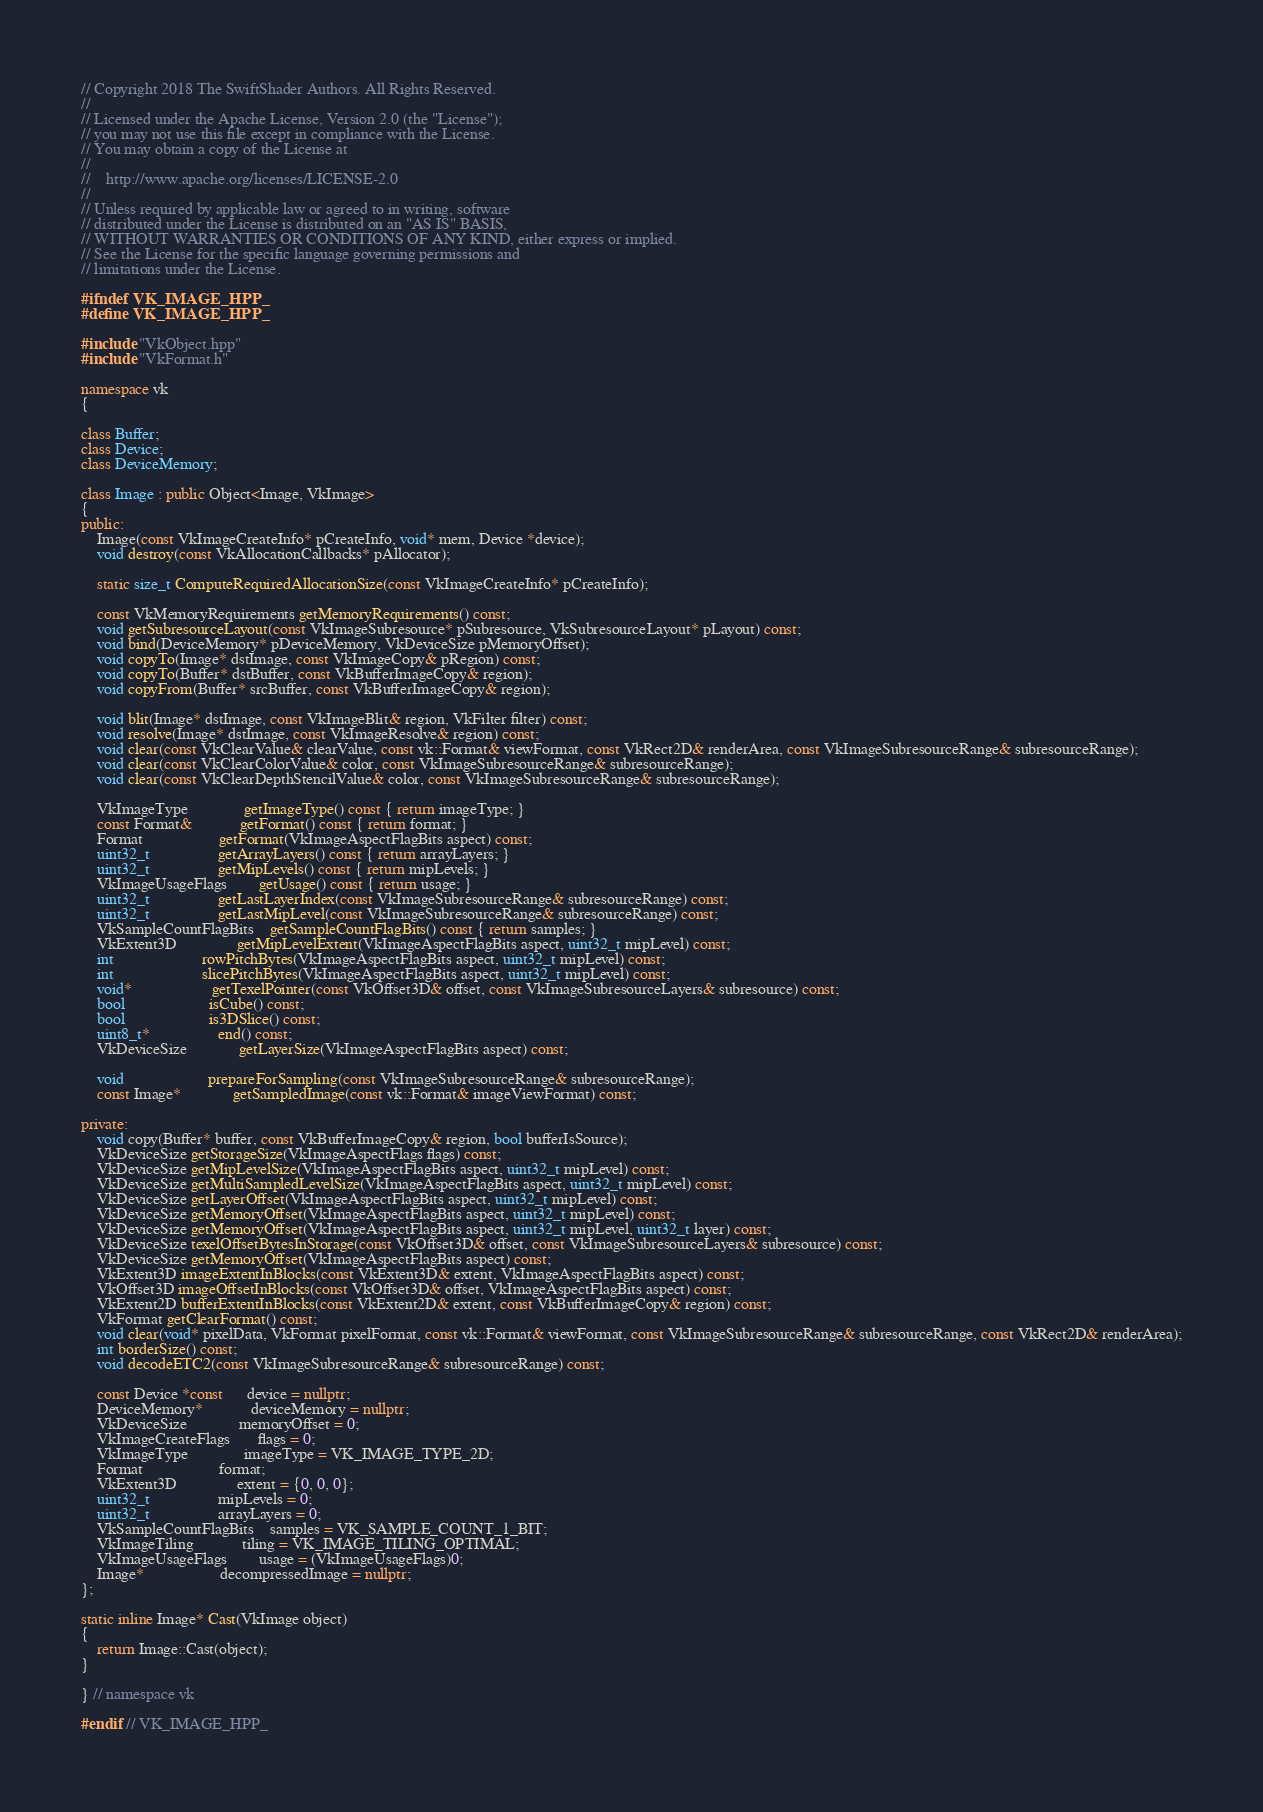<code> <loc_0><loc_0><loc_500><loc_500><_C++_>// Copyright 2018 The SwiftShader Authors. All Rights Reserved.
//
// Licensed under the Apache License, Version 2.0 (the "License");
// you may not use this file except in compliance with the License.
// You may obtain a copy of the License at
//
//    http://www.apache.org/licenses/LICENSE-2.0
//
// Unless required by applicable law or agreed to in writing, software
// distributed under the License is distributed on an "AS IS" BASIS,
// WITHOUT WARRANTIES OR CONDITIONS OF ANY KIND, either express or implied.
// See the License for the specific language governing permissions and
// limitations under the License.

#ifndef VK_IMAGE_HPP_
#define VK_IMAGE_HPP_

#include "VkObject.hpp"
#include "VkFormat.h"

namespace vk
{

class Buffer;
class Device;
class DeviceMemory;

class Image : public Object<Image, VkImage>
{
public:
	Image(const VkImageCreateInfo* pCreateInfo, void* mem, Device *device);
	void destroy(const VkAllocationCallbacks* pAllocator);

	static size_t ComputeRequiredAllocationSize(const VkImageCreateInfo* pCreateInfo);

	const VkMemoryRequirements getMemoryRequirements() const;
	void getSubresourceLayout(const VkImageSubresource* pSubresource, VkSubresourceLayout* pLayout) const;
	void bind(DeviceMemory* pDeviceMemory, VkDeviceSize pMemoryOffset);
	void copyTo(Image* dstImage, const VkImageCopy& pRegion) const;
	void copyTo(Buffer* dstBuffer, const VkBufferImageCopy& region);
	void copyFrom(Buffer* srcBuffer, const VkBufferImageCopy& region);

	void blit(Image* dstImage, const VkImageBlit& region, VkFilter filter) const;
	void resolve(Image* dstImage, const VkImageResolve& region) const;
	void clear(const VkClearValue& clearValue, const vk::Format& viewFormat, const VkRect2D& renderArea, const VkImageSubresourceRange& subresourceRange);
	void clear(const VkClearColorValue& color, const VkImageSubresourceRange& subresourceRange);
	void clear(const VkClearDepthStencilValue& color, const VkImageSubresourceRange& subresourceRange);

	VkImageType              getImageType() const { return imageType; }
	const Format&            getFormat() const { return format; }
	Format                   getFormat(VkImageAspectFlagBits aspect) const;
	uint32_t                 getArrayLayers() const { return arrayLayers; }
	uint32_t                 getMipLevels() const { return mipLevels; }
	VkImageUsageFlags        getUsage() const { return usage; }
	uint32_t                 getLastLayerIndex(const VkImageSubresourceRange& subresourceRange) const;
	uint32_t                 getLastMipLevel(const VkImageSubresourceRange& subresourceRange) const;
	VkSampleCountFlagBits    getSampleCountFlagBits() const { return samples; }
	VkExtent3D               getMipLevelExtent(VkImageAspectFlagBits aspect, uint32_t mipLevel) const;
	int                      rowPitchBytes(VkImageAspectFlagBits aspect, uint32_t mipLevel) const;
	int                      slicePitchBytes(VkImageAspectFlagBits aspect, uint32_t mipLevel) const;
	void*                    getTexelPointer(const VkOffset3D& offset, const VkImageSubresourceLayers& subresource) const;
	bool                     isCube() const;
	bool                     is3DSlice() const;
	uint8_t*                 end() const;
	VkDeviceSize             getLayerSize(VkImageAspectFlagBits aspect) const;

	void                     prepareForSampling(const VkImageSubresourceRange& subresourceRange);
	const Image*             getSampledImage(const vk::Format& imageViewFormat) const;

private:
	void copy(Buffer* buffer, const VkBufferImageCopy& region, bool bufferIsSource);
	VkDeviceSize getStorageSize(VkImageAspectFlags flags) const;
	VkDeviceSize getMipLevelSize(VkImageAspectFlagBits aspect, uint32_t mipLevel) const;
	VkDeviceSize getMultiSampledLevelSize(VkImageAspectFlagBits aspect, uint32_t mipLevel) const;
	VkDeviceSize getLayerOffset(VkImageAspectFlagBits aspect, uint32_t mipLevel) const;
	VkDeviceSize getMemoryOffset(VkImageAspectFlagBits aspect, uint32_t mipLevel) const;
	VkDeviceSize getMemoryOffset(VkImageAspectFlagBits aspect, uint32_t mipLevel, uint32_t layer) const;
	VkDeviceSize texelOffsetBytesInStorage(const VkOffset3D& offset, const VkImageSubresourceLayers& subresource) const;
	VkDeviceSize getMemoryOffset(VkImageAspectFlagBits aspect) const;
	VkExtent3D imageExtentInBlocks(const VkExtent3D& extent, VkImageAspectFlagBits aspect) const;
	VkOffset3D imageOffsetInBlocks(const VkOffset3D& offset, VkImageAspectFlagBits aspect) const;
	VkExtent2D bufferExtentInBlocks(const VkExtent2D& extent, const VkBufferImageCopy& region) const;
	VkFormat getClearFormat() const;
	void clear(void* pixelData, VkFormat pixelFormat, const vk::Format& viewFormat, const VkImageSubresourceRange& subresourceRange, const VkRect2D& renderArea);
	int borderSize() const;
	void decodeETC2(const VkImageSubresourceRange& subresourceRange) const;

	const Device *const      device = nullptr;
	DeviceMemory*            deviceMemory = nullptr;
	VkDeviceSize             memoryOffset = 0;
	VkImageCreateFlags       flags = 0;
	VkImageType              imageType = VK_IMAGE_TYPE_2D;
	Format                   format;
	VkExtent3D               extent = {0, 0, 0};
	uint32_t                 mipLevels = 0;
	uint32_t                 arrayLayers = 0;
	VkSampleCountFlagBits    samples = VK_SAMPLE_COUNT_1_BIT;
	VkImageTiling            tiling = VK_IMAGE_TILING_OPTIMAL;
	VkImageUsageFlags        usage = (VkImageUsageFlags)0;
	Image*                   decompressedImage = nullptr;
};

static inline Image* Cast(VkImage object)
{
	return Image::Cast(object);
}

} // namespace vk

#endif // VK_IMAGE_HPP_</code> 